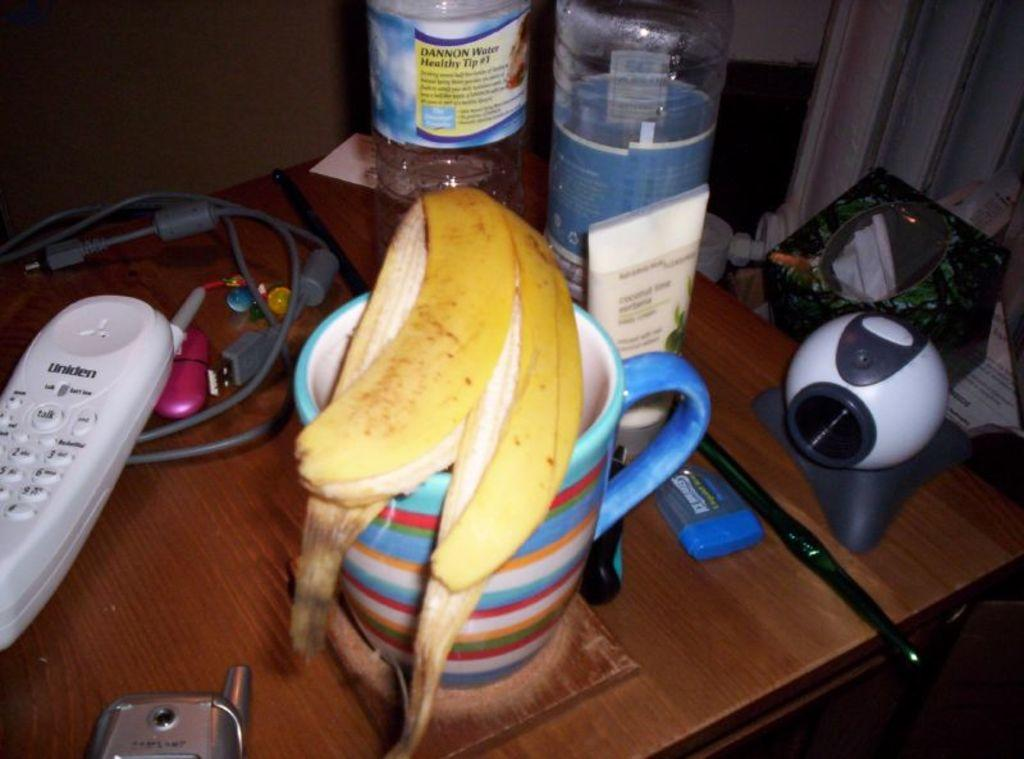Provide a one-sentence caption for the provided image. A banana peel is on a coffee cup and next to a Uniden phone. 